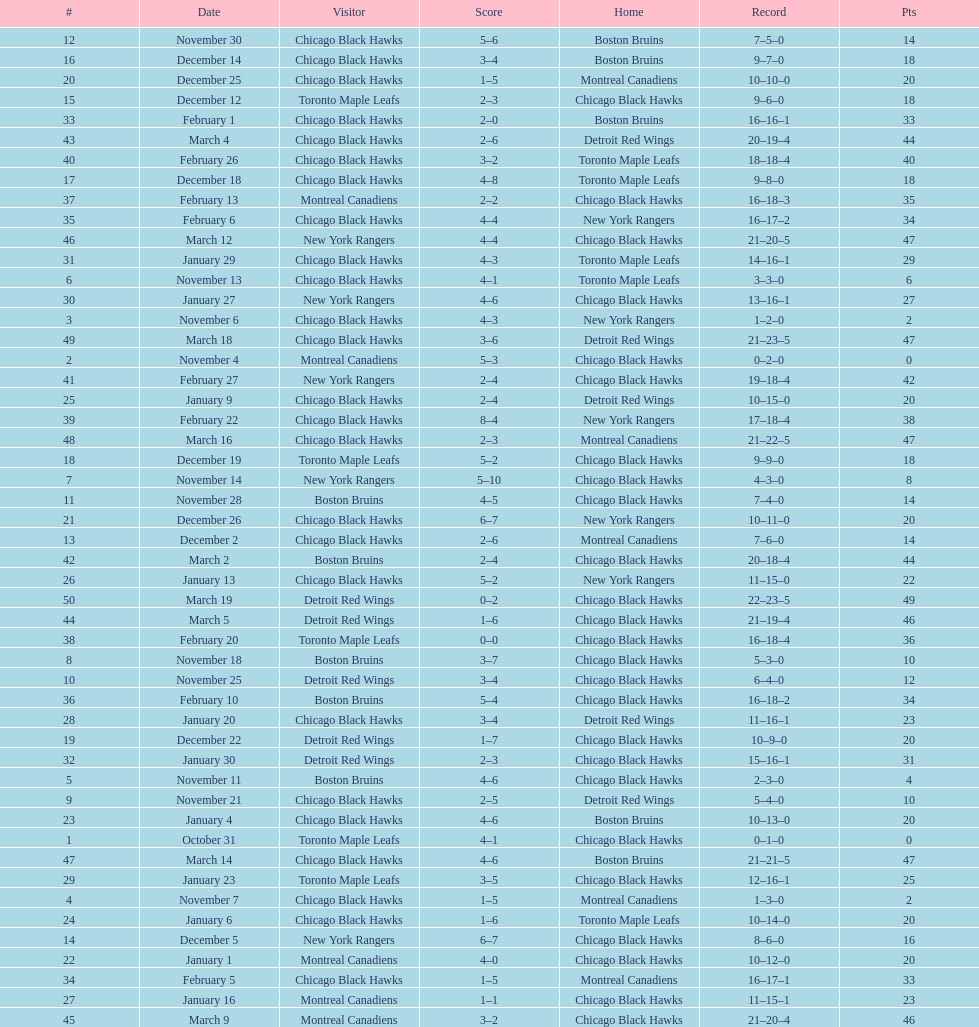What is was the difference in score in the december 19th win? 3. 